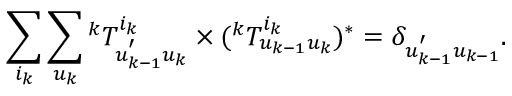Convert formula to latex. <formula><loc_0><loc_0><loc_500><loc_500>\sum _ { i _ { k } } { \sum _ { u _ { k } } { { ^ { k } T _ { u _ { k - 1 } ^ { ^ { \prime } } u _ { k } } ^ { i _ { k } } } \times ( { ^ { k } T _ { u _ { k - 1 } u _ { k } } ^ { i _ { k } } } ) ^ { * } } } = \delta _ { u _ { k - 1 } ^ { ^ { \prime } } u _ { k - 1 } } .</formula> 